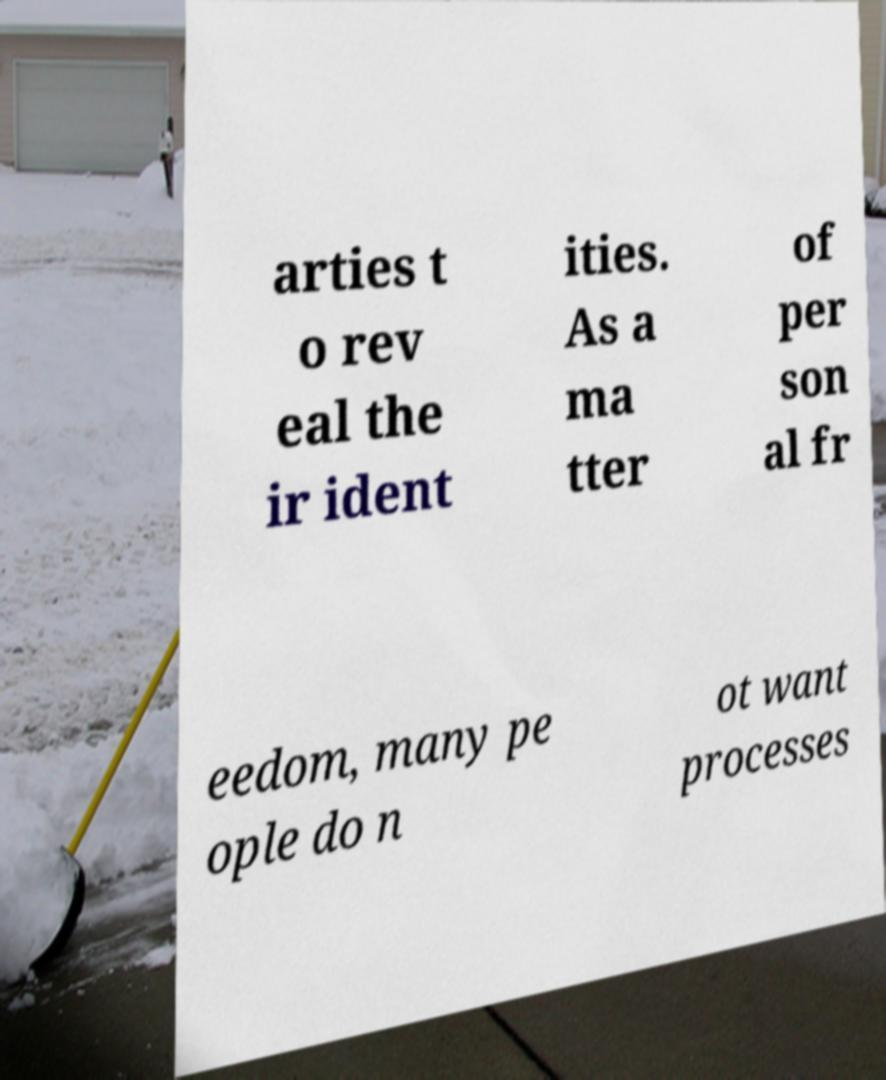I need the written content from this picture converted into text. Can you do that? arties t o rev eal the ir ident ities. As a ma tter of per son al fr eedom, many pe ople do n ot want processes 